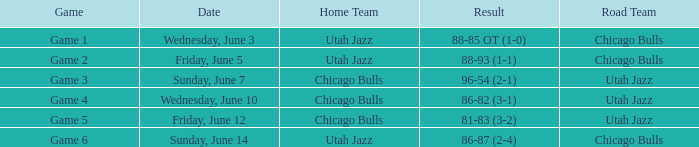Result of 86-87 (2-4) is what game? Game 6. 